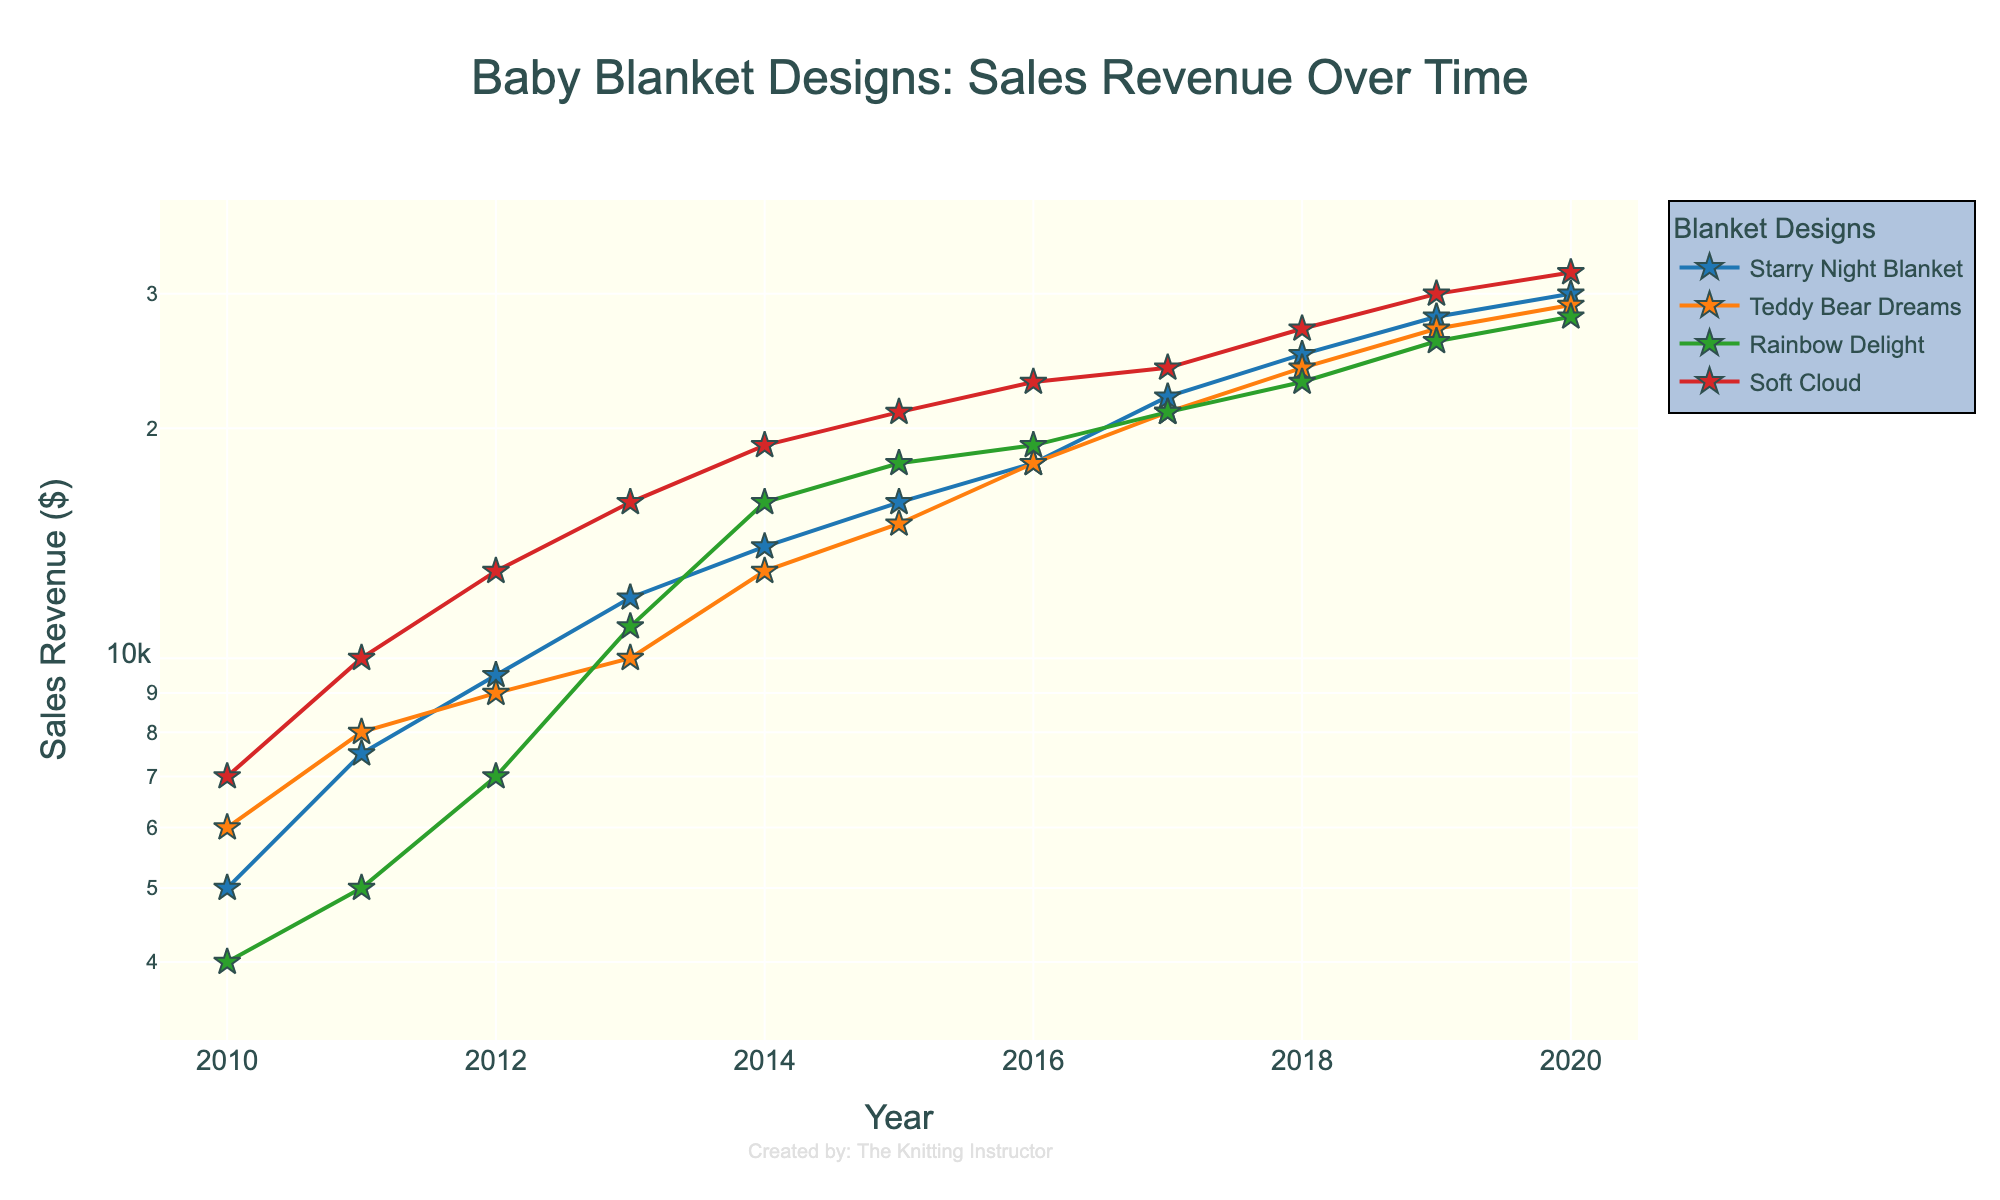How many designs are plotted in the figure? There are distinct lines on the plot, each representing a different design, and there is a legend indicating four different blanket designs: "Starry Night Blanket," "Teddy Bear Dreams," "Rainbow Delight," and "Soft Cloud."
Answer: Four Which design had the highest sales revenue in 2020? By looking at the data points for 2020, the "Soft Cloud" design has the highest sales revenue as it is the highest point on the y-axis in that year compared to other designs.
Answer: Soft Cloud What is the title of the plot? The title of the plot is indicated at the top and reads "Baby Blanket Designs: Sales Revenue Over Time."
Answer: Baby Blanket Designs: Sales Revenue Over Time Which design had a higher sales revenue in 2014, "Starry Night Blanket" or "Teddy Bear Dreams"? Check the y-values for both designs in 2014; "Starry Night Blanket" has a sales revenue of $14,000, while "Teddy Bear Dreams" has $13,000. Therefore, "Starry Night Blanket" has higher sales.
Answer: Starry Night Blanket Across which years did the "Rainbow Delight" design see the highest percentage increase in sales revenue? To find the highest percentage increase, calculate the year-to-year growth rates for "Rainbow Delight" and find the maximum percentage. The steepest slope occurs between 2013 and 2014, where sales rose from $11,000 to $16,000, an increase of about 45.45%.
Answer: 2013 to 2014 What is the sales revenue range (minimum to maximum) for "Starry Night Blanket" over the decade? Identify the minimum and maximum y-values for "Starry Night Blanket"; the minimum is $5,000 in 2010, and the maximum is $30,000 in 2020.
Answer: $5,000 to $30,000 Which year saw the largest collective sales revenue for all designs? Sum the sales revenue for all designs in each year and find the year with the highest total. In 2020, the sales revenues are $30,000 (Starry Night Blanket) + $29,000 (Teddy Bear Dreams) + $28,000 (Rainbow Delight) + $32,000 (Soft Cloud), totaling $119,000.
Answer: 2020 Describe the trend in sales revenue for "Soft Cloud" from 2010 to 2020. The sales revenue for "Soft Cloud" shows a consistent upward trend from $7,000 in 2010 to $32,000 in 2020, with no significant downturns or plateaus.
Answer: Consistent upward trend How does the sales revenue of "Teddy Bear Dreams" in 2015 compare to "Rainbow Delight" in 2015? In 2015, "Teddy Bear Dreams" has a sales revenue of $15,000 while "Rainbow Delight" has $18,000. Comparing these values, "Rainbow Delight" has a higher sales revenue.
Answer: Rainbow Delight is higher What is the average sales revenue for "Soft Cloud" from 2010 to 2020? Add the sales revenues for "Soft Cloud" for each year from 2010 to 2020 (sum is $219,000) and divide by the number of years, 11. The average is $219,000 / 11 ≈ $19,909.09.
Answer: Approximately $19,909.09 